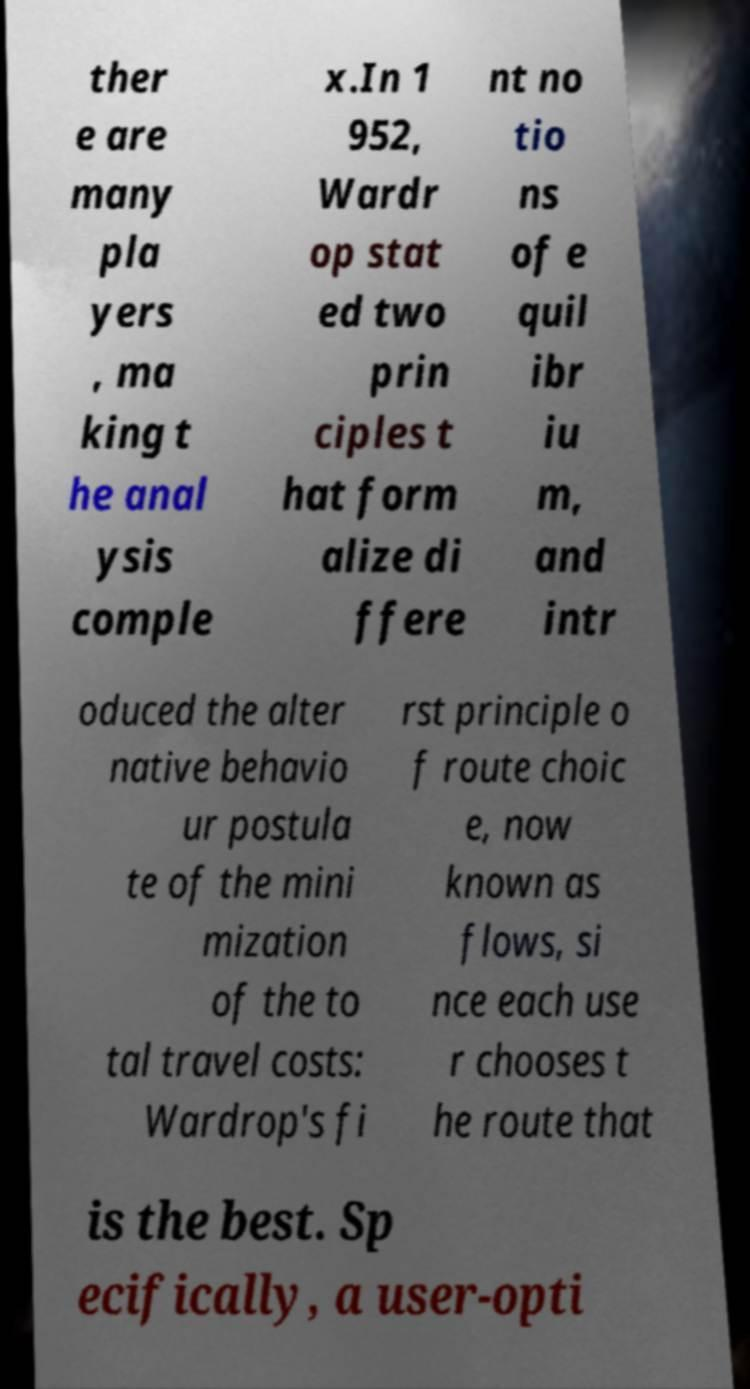Please identify and transcribe the text found in this image. ther e are many pla yers , ma king t he anal ysis comple x.In 1 952, Wardr op stat ed two prin ciples t hat form alize di ffere nt no tio ns of e quil ibr iu m, and intr oduced the alter native behavio ur postula te of the mini mization of the to tal travel costs: Wardrop's fi rst principle o f route choic e, now known as flows, si nce each use r chooses t he route that is the best. Sp ecifically, a user-opti 